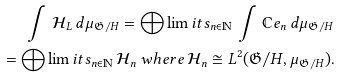Convert formula to latex. <formula><loc_0><loc_0><loc_500><loc_500>\int \, \mathcal { H } _ { L } \, d \mu _ { \mathfrak { G } / H } = \bigoplus \lim i t s _ { n \in \mathbb { N } } \, \int \, \mathbb { C } e _ { n } \, d \mu _ { \mathfrak { G } / H } \\ = \bigoplus \lim i t s _ { n \in \mathbb { N } } \, \mathcal { H } _ { n } \, w h e r e \, \mathcal { H } _ { n } \cong L ^ { 2 } ( \mathfrak { G } / H , \mu _ { \mathfrak { G } / H } ) .</formula> 